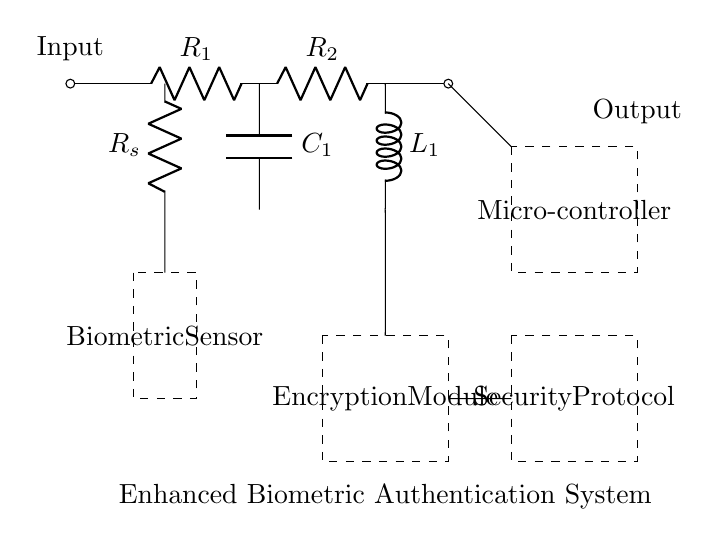What type of sensor is used in this circuit? The circuit uses a biometric sensor, indicated by the labeled dashed rectangle that encapsulates this component.
Answer: biometric sensor What components are in series with the output? The output goes through both resistors, R1 and R2, in series before reaching the output node.
Answer: R1, R2 What is the purpose of the encryption module in this circuit? The encryption module processes signals from the circuit to enhance security, making data secure before transmission or storage.
Answer: enhance security How many passive components are present in this circuit? There are three passive components: two resistors (R1 and R2) and one capacitor (C1).
Answer: three What is connected directly to the microcontroller? The microcontroller is connected directly to the output from the last resistor, R2.
Answer: output from R2 Which components are involved in data processing within the authentication system? The major components involved in data processing are the biometric sensor and the microcontroller, as well as the encryption module that secures the data.
Answer: biometric sensor, microcontroller, encryption module How does the security protocol relate to the encryption module? The security protocol is connected downstream of the encryption module, indicating that it likely utilizes the encrypted data for security measures.
Answer: utilizes encrypted data 